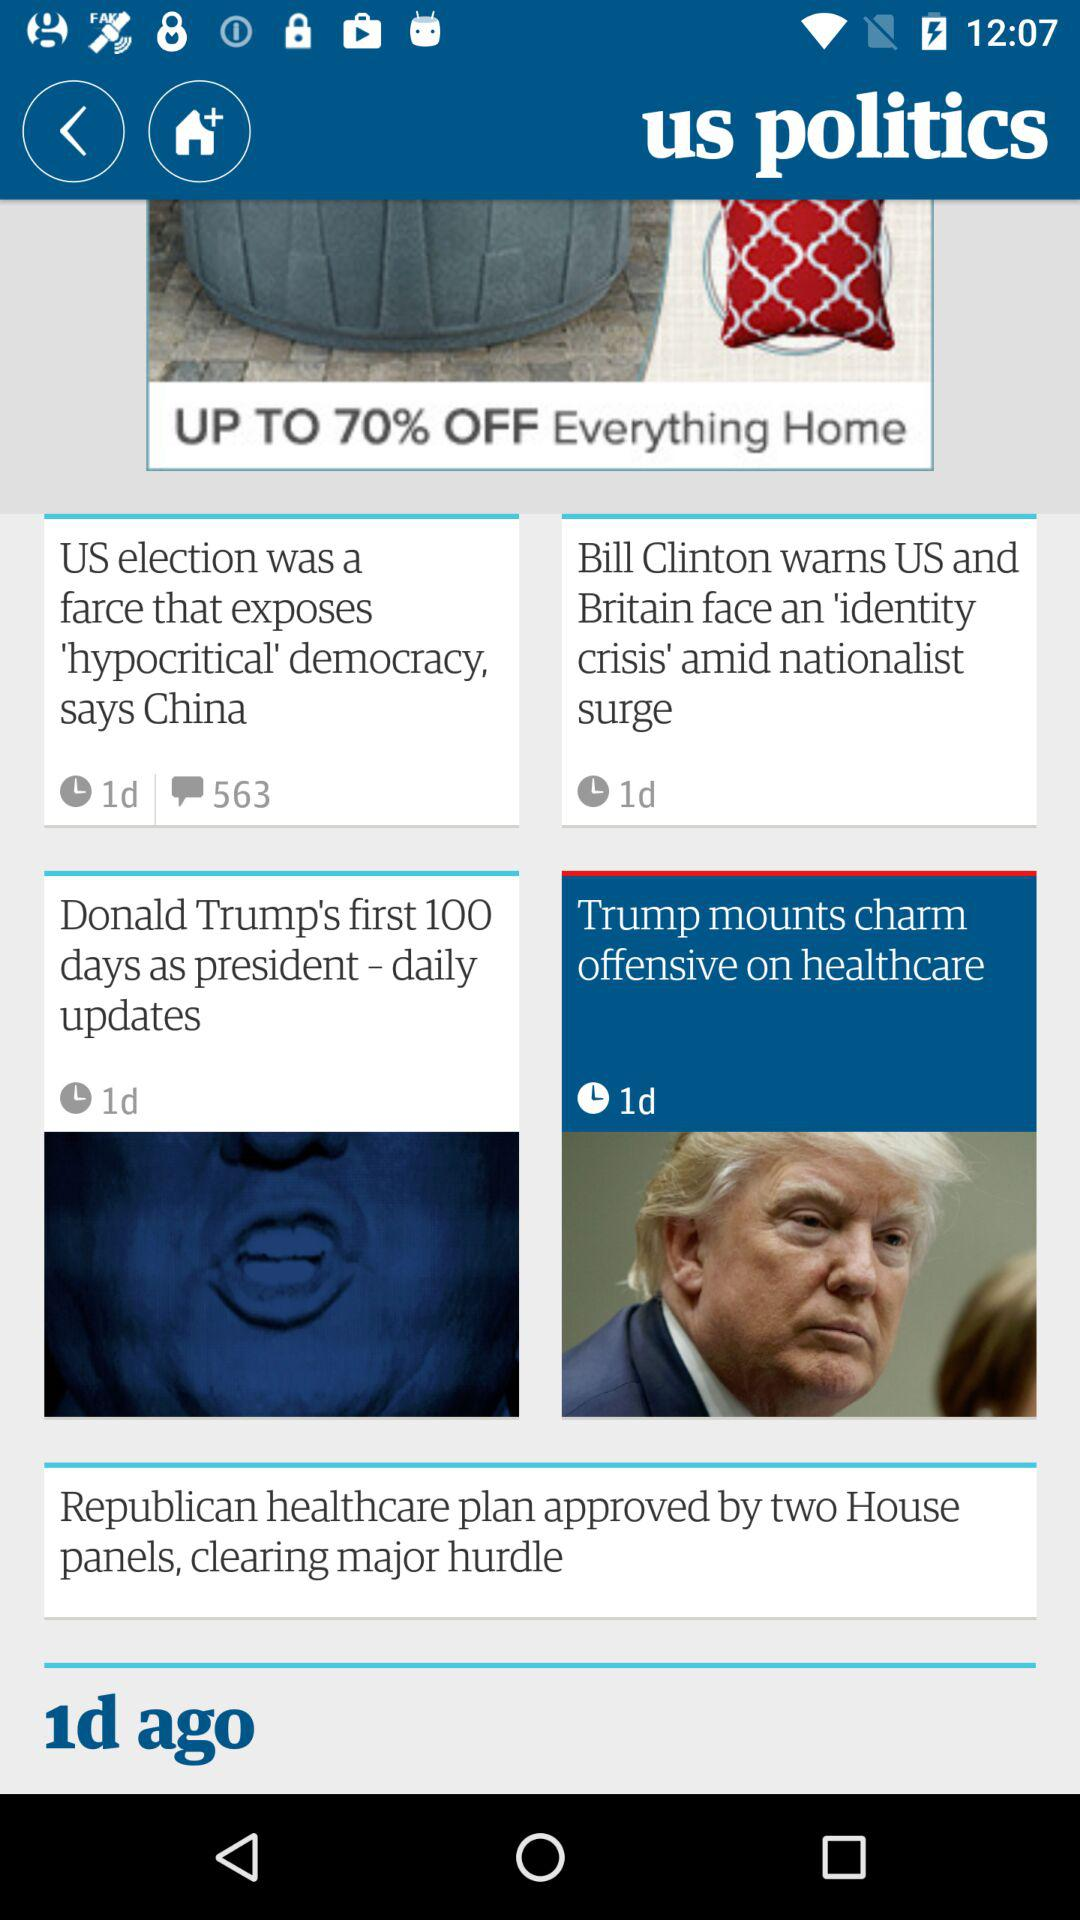When was Donald Trump's news posted? It was posted 1 day ago. 